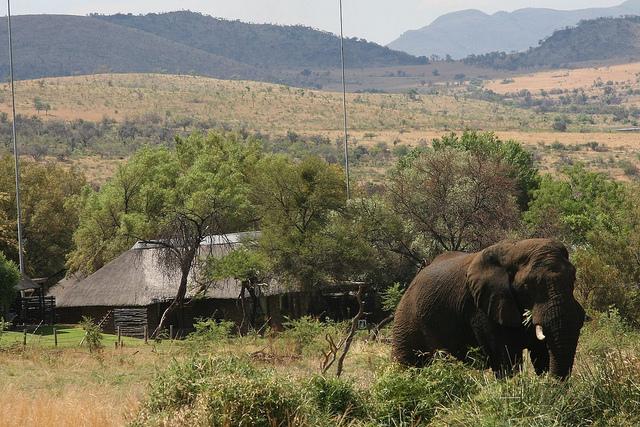Where was the picture of the elephant and barn taken?
Be succinct. Africa. Is this a city or countryside?
Write a very short answer. Countryside. What is this animal?
Keep it brief. Elephant. Can you ride this elephant?
Quick response, please. No. 